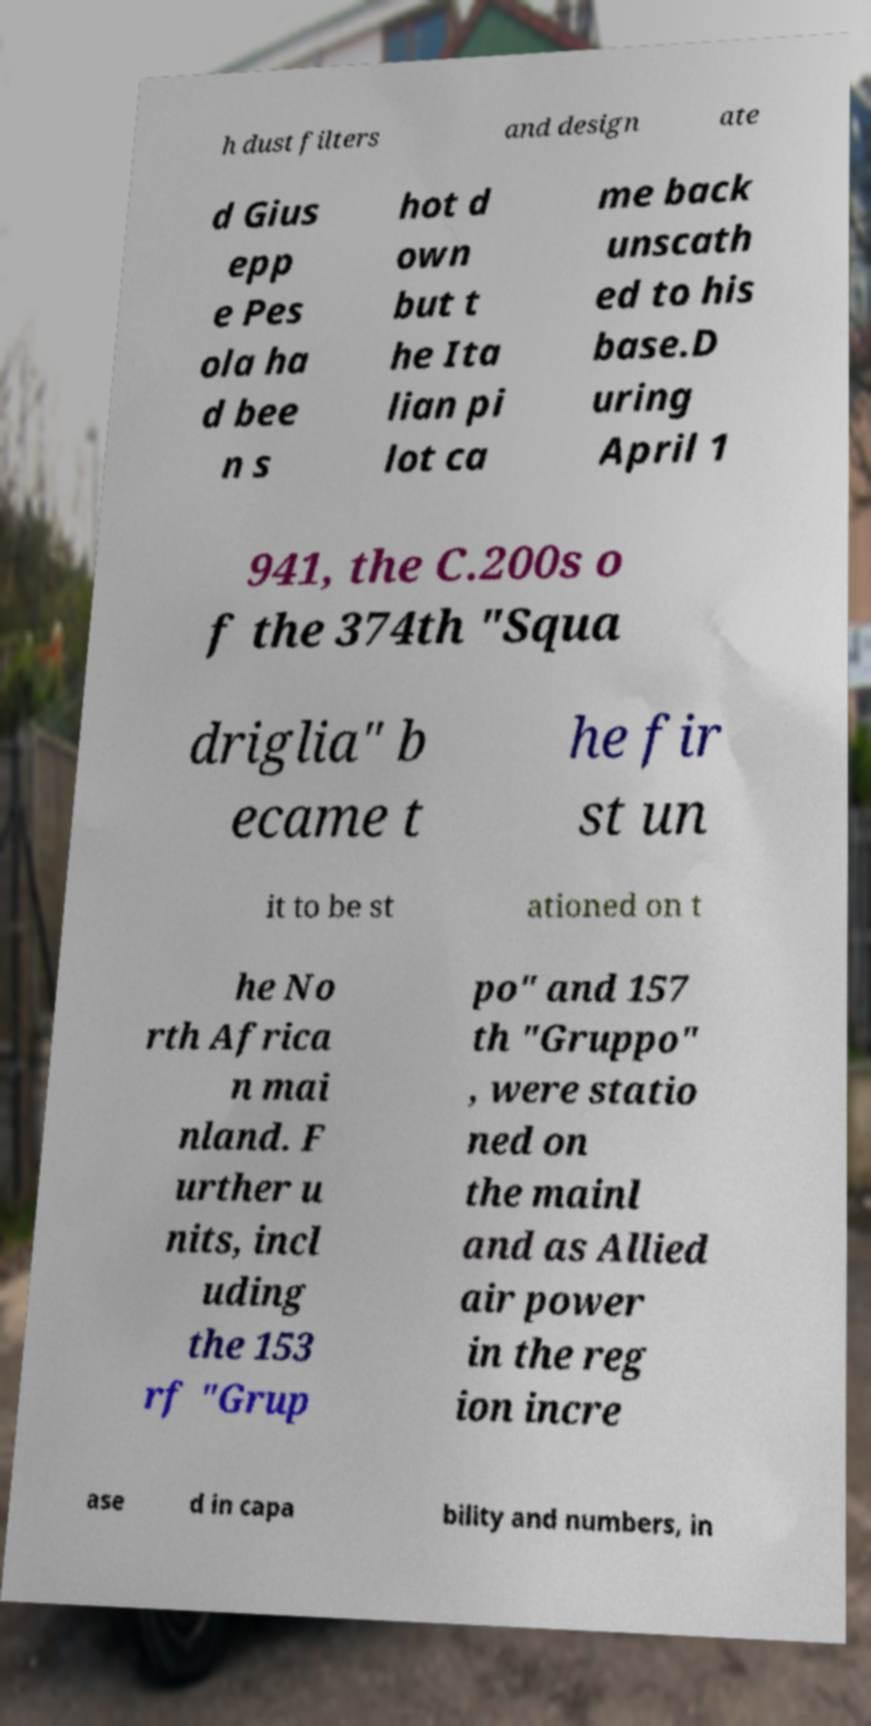Please read and relay the text visible in this image. What does it say? h dust filters and design ate d Gius epp e Pes ola ha d bee n s hot d own but t he Ita lian pi lot ca me back unscath ed to his base.D uring April 1 941, the C.200s o f the 374th "Squa driglia" b ecame t he fir st un it to be st ationed on t he No rth Africa n mai nland. F urther u nits, incl uding the 153 rf "Grup po" and 157 th "Gruppo" , were statio ned on the mainl and as Allied air power in the reg ion incre ase d in capa bility and numbers, in 